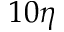Convert formula to latex. <formula><loc_0><loc_0><loc_500><loc_500>1 0 \eta</formula> 